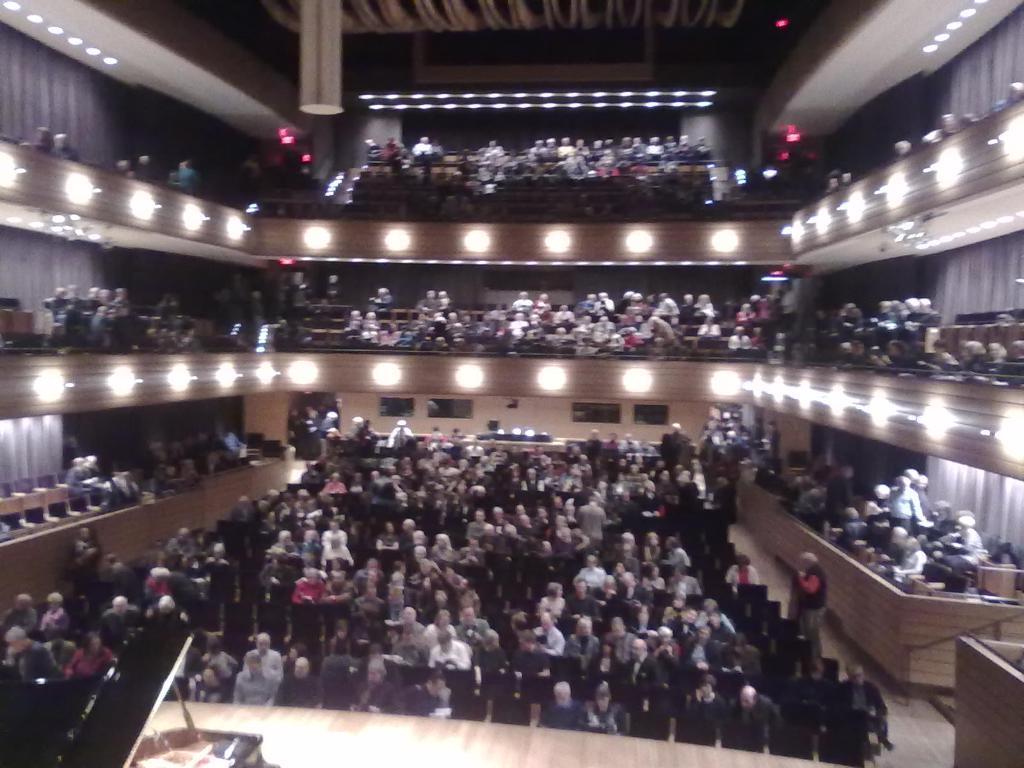In one or two sentences, can you explain what this image depicts? In the picture I can see people among them some are standing and some are sitting on chairs. Here I can see fence, lights, a piano on the stage, ceiling and some other objects. 